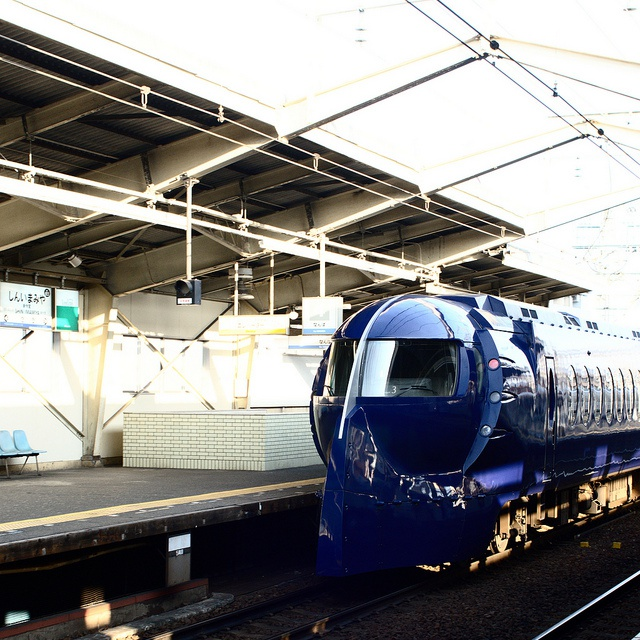Describe the objects in this image and their specific colors. I can see train in white, black, navy, and gray tones, chair in white, lightblue, black, and gray tones, and chair in white, lightblue, lightgray, and black tones in this image. 